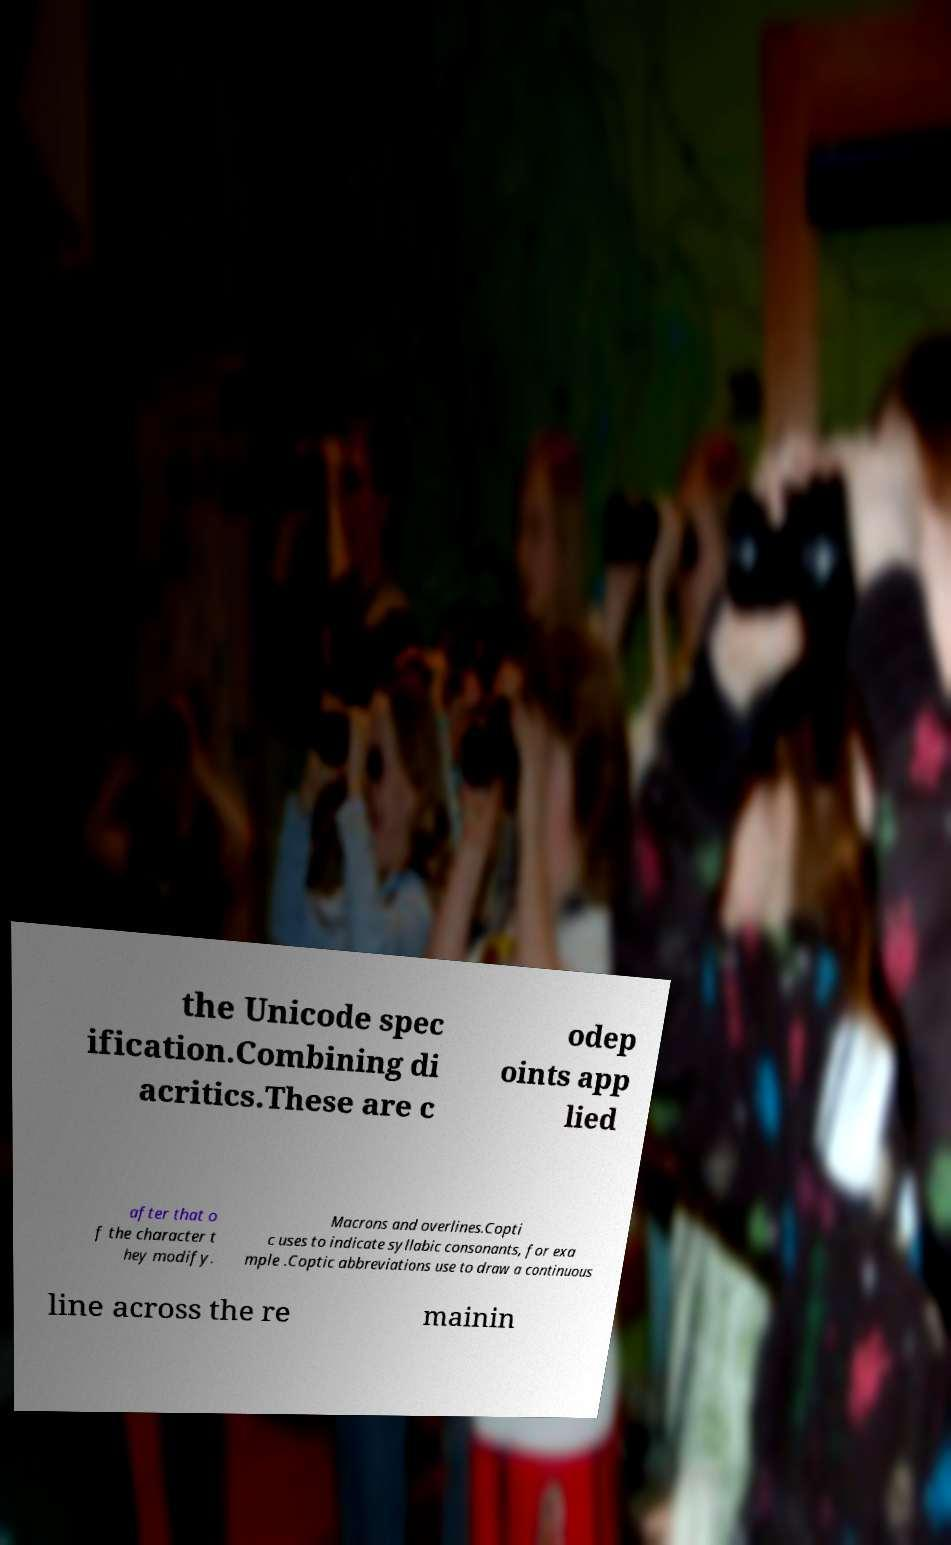Please read and relay the text visible in this image. What does it say? the Unicode spec ification.Combining di acritics.These are c odep oints app lied after that o f the character t hey modify. Macrons and overlines.Copti c uses to indicate syllabic consonants, for exa mple .Coptic abbreviations use to draw a continuous line across the re mainin 